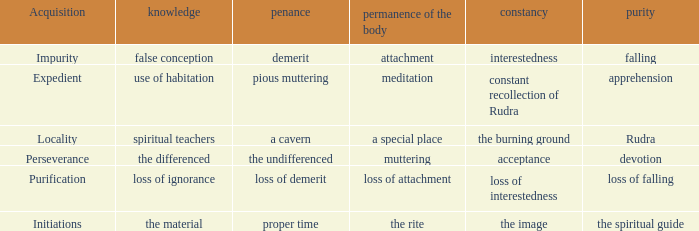What is the total number of constancy where purity is falling 1.0. 